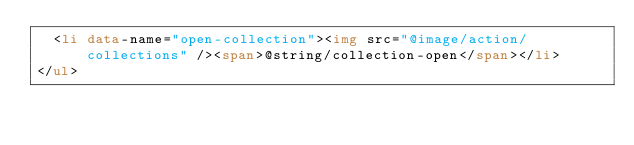Convert code to text. <code><loc_0><loc_0><loc_500><loc_500><_HTML_>	<li data-name="open-collection"><img src="@image/action/collections" /><span>@string/collection-open</span></li>
</ul>
</code> 